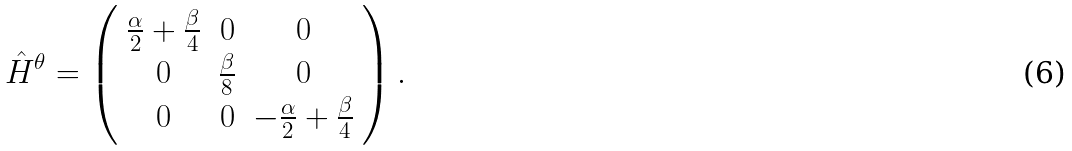Convert formula to latex. <formula><loc_0><loc_0><loc_500><loc_500>\hat { H } ^ { \theta } = \left ( \begin{array} { c c c } \frac { \alpha } { 2 } + \frac { \beta } { 4 } & 0 & 0 \\ 0 & \frac { \beta } { 8 } & 0 \\ 0 & 0 & - \frac { \alpha } { 2 } + \frac { \beta } { 4 } \end{array} \right ) .</formula> 